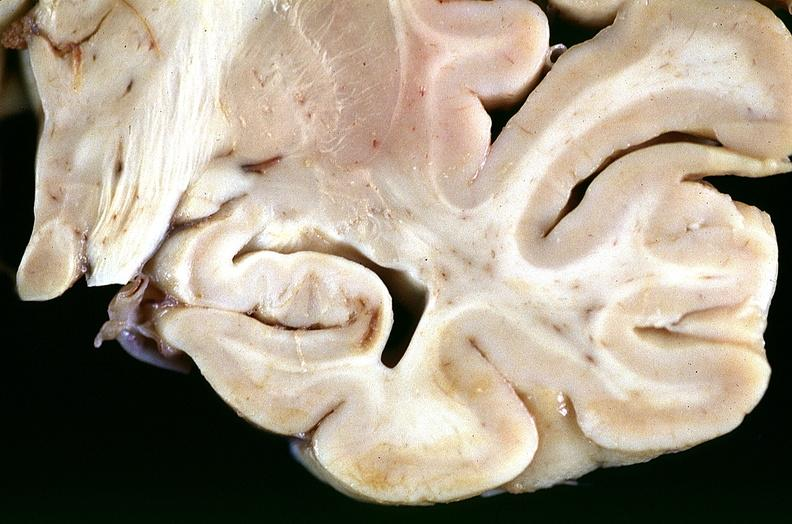what does this image show?
Answer the question using a single word or phrase. Brain 